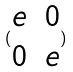<formula> <loc_0><loc_0><loc_500><loc_500>( \begin{matrix} e & 0 \\ 0 & e \end{matrix} )</formula> 